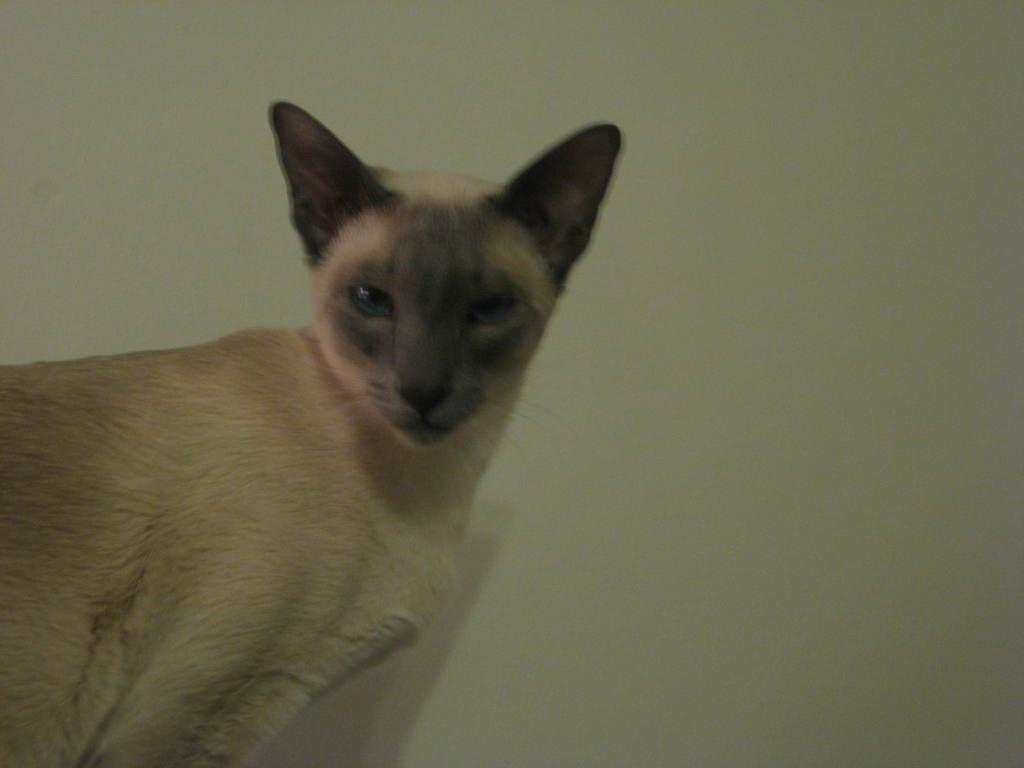What animal is located on the left side of the image? There is a cat on the left side of the image. What can be seen in the background of the image? There is a wall in the background of the image. What color is the wall in the image? The wall is painted white. How many men are visible in the image? There are no men present in the image; it features a cat and a white wall. What type of picture is the cat holding in the image? There is no picture present in the image, and the cat is not holding anything. 